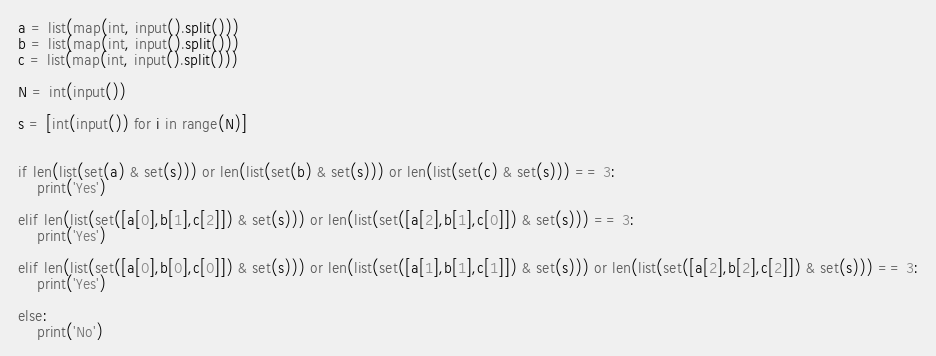Convert code to text. <code><loc_0><loc_0><loc_500><loc_500><_Python_>a = list(map(int, input().split()))
b = list(map(int, input().split()))
c = list(map(int, input().split()))

N = int(input())

s = [int(input()) for i in range(N)]


if len(list(set(a) & set(s))) or len(list(set(b) & set(s))) or len(list(set(c) & set(s))) == 3:
    print('Yes')

elif len(list(set([a[0],b[1],c[2]]) & set(s))) or len(list(set([a[2],b[1],c[0]]) & set(s))) == 3:
    print('Yes')

elif len(list(set([a[0],b[0],c[0]]) & set(s))) or len(list(set([a[1],b[1],c[1]]) & set(s))) or len(list(set([a[2],b[2],c[2]]) & set(s))) == 3:
    print('Yes')

else:
    print('No')</code> 